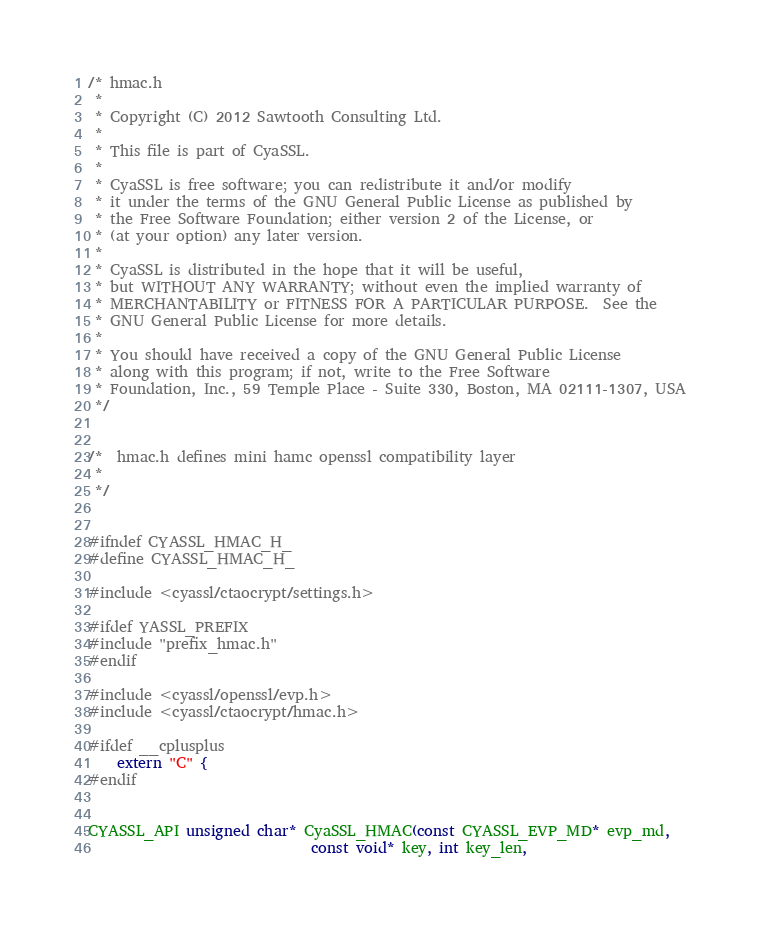<code> <loc_0><loc_0><loc_500><loc_500><_C_>/* hmac.h
 *
 * Copyright (C) 2012 Sawtooth Consulting Ltd.
 *
 * This file is part of CyaSSL.
 *
 * CyaSSL is free software; you can redistribute it and/or modify
 * it under the terms of the GNU General Public License as published by
 * the Free Software Foundation; either version 2 of the License, or
 * (at your option) any later version.
 *
 * CyaSSL is distributed in the hope that it will be useful,
 * but WITHOUT ANY WARRANTY; without even the implied warranty of
 * MERCHANTABILITY or FITNESS FOR A PARTICULAR PURPOSE.  See the
 * GNU General Public License for more details.
 *
 * You should have received a copy of the GNU General Public License
 * along with this program; if not, write to the Free Software
 * Foundation, Inc., 59 Temple Place - Suite 330, Boston, MA 02111-1307, USA
 */


/*  hmac.h defines mini hamc openssl compatibility layer 
 *
 */


#ifndef CYASSL_HMAC_H_
#define CYASSL_HMAC_H_

#include <cyassl/ctaocrypt/settings.h>

#ifdef YASSL_PREFIX
#include "prefix_hmac.h"
#endif

#include <cyassl/openssl/evp.h>
#include <cyassl/ctaocrypt/hmac.h>

#ifdef __cplusplus
    extern "C" {
#endif


CYASSL_API unsigned char* CyaSSL_HMAC(const CYASSL_EVP_MD* evp_md,
                               const void* key, int key_len,</code> 